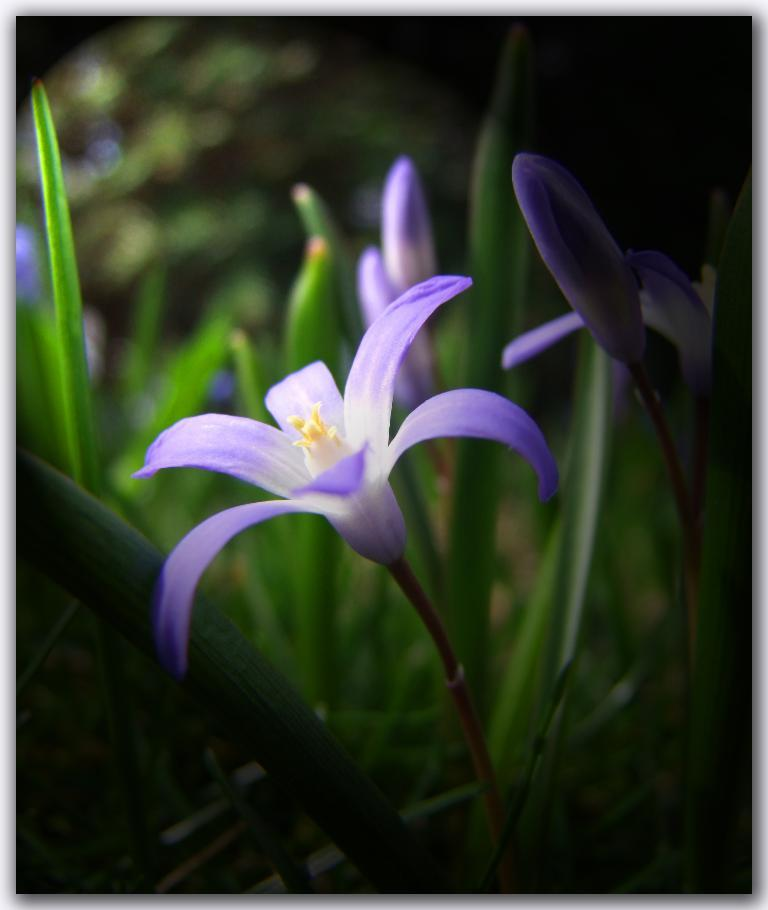What type of plant life is visible in the image? There are flowers, flower buds, and leaves visible in the image. Can you describe the different stages of growth seen in the image? The image shows flowers, which are fully bloomed, and flower buds, which are in the process of blooming. What other parts of the plants can be seen in the image? Leaves are also present in the image. What action is the flower performing in the image? Flowers do not perform actions in the way humans or animals do; they are stationary plants. How many drops of water can be seen falling on the flower in the image? There are no drops of water visible in the image. 